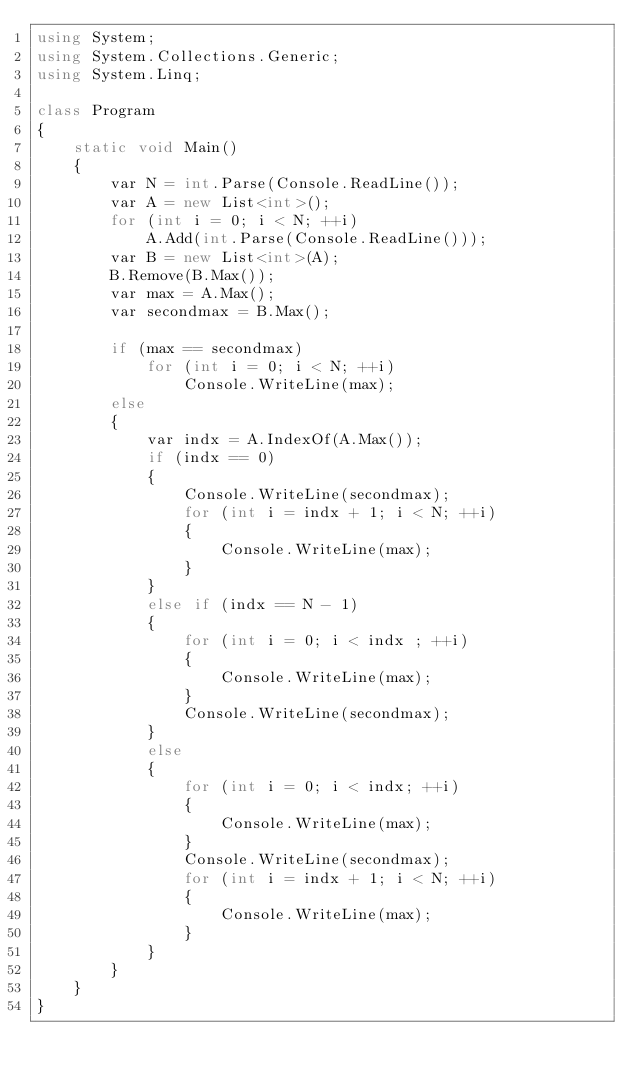Convert code to text. <code><loc_0><loc_0><loc_500><loc_500><_C#_>using System;
using System.Collections.Generic;
using System.Linq;

class Program
{
    static void Main()
    {
        var N = int.Parse(Console.ReadLine());
        var A = new List<int>();
        for (int i = 0; i < N; ++i)
            A.Add(int.Parse(Console.ReadLine()));
        var B = new List<int>(A);
        B.Remove(B.Max());
        var max = A.Max();
        var secondmax = B.Max();

        if (max == secondmax)
            for (int i = 0; i < N; ++i)
                Console.WriteLine(max);
        else
        {
            var indx = A.IndexOf(A.Max());
            if (indx == 0)
            {
                Console.WriteLine(secondmax);
                for (int i = indx + 1; i < N; ++i)
                {
                    Console.WriteLine(max);
                }
            }
            else if (indx == N - 1)
            {
                for (int i = 0; i < indx ; ++i)
                {
                    Console.WriteLine(max);
                }
                Console.WriteLine(secondmax);
            }
            else
            {
                for (int i = 0; i < indx; ++i)
                {
                    Console.WriteLine(max);
                }
                Console.WriteLine(secondmax);
                for (int i = indx + 1; i < N; ++i)
                {
                    Console.WriteLine(max);
                }
            }
        }
    }
}

</code> 